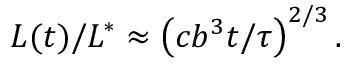<formula> <loc_0><loc_0><loc_500><loc_500>{ L ( t ) } / { L ^ { * } } \approx \left ( { c b ^ { 3 } t } / { \tau } \right ) ^ { 2 / 3 } .</formula> 